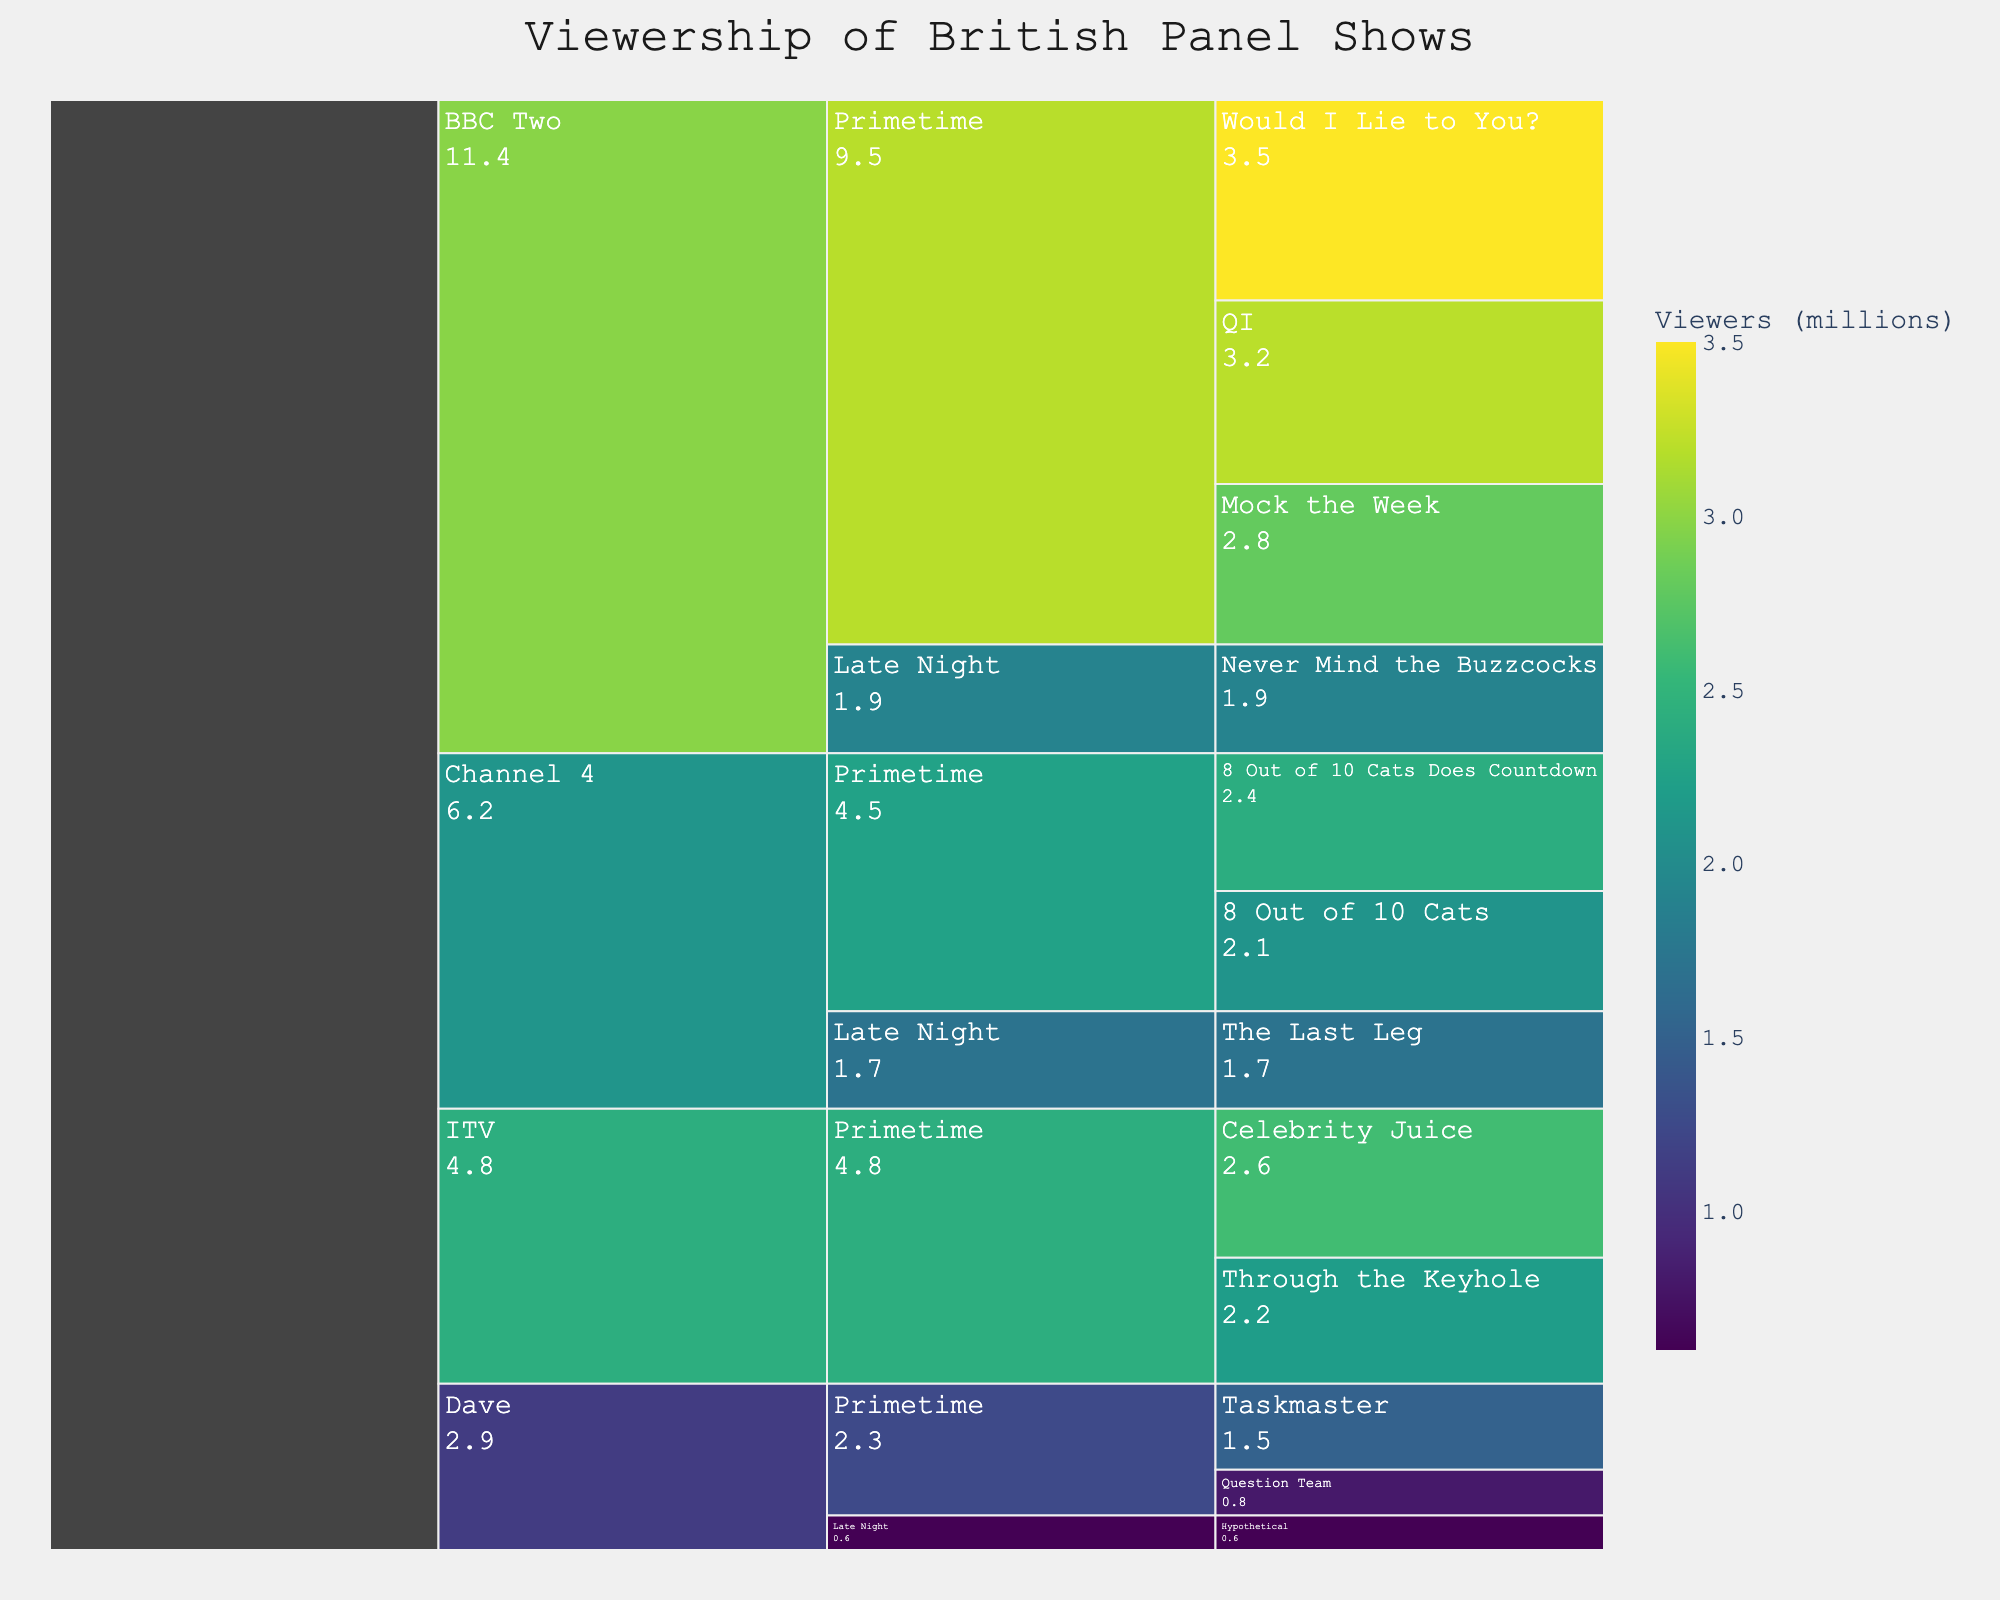How many channels are presented in the figure? The figure categorizes the data by channels, which are BBC Two, Channel 4, ITV, and Dave. Counting these gives a total of four channels.
Answer: Four Which show on BBC Two has the highest viewership? Navigate to the BBC Two subtree and compare the values of the shows listed. "Would I Lie to You?" has the largest value at 3.5 million viewers.
Answer: Would I Lie to You? What's the combined viewership of the IT and Channel 4 panel shows during Primetime? Add the viewership of Primetime shows under both channels. For Channel 4: 8 Out of 10 Cats (2.1) + 8 Out of 10 Cats Does Countdown (2.4) = 4.5 million. For ITV: Celebrity Juice (2.6) + Through the Keyhole (2.2) = 4.8 million. The combined viewership is 4.5 + 4.8 = 9.3 million.
Answer: 9.3 million What's the difference in viewership between the highest and lowest watched shows on Dave? Identify the highest (Taskmaster with 1.5 million) and lowest (Hypothetical with 0.6 million) viewed shows on Dave. Calculate the difference: 1.5 - 0.6 = 0.9 million.
Answer: 0.9 million Which channel has the least number of viewers during the Late Night time slot? Navigate to the Late Night subtree for each channel. Dave shows Hypothetical with 0.6 million viewers. Channel 4 shows The Last Leg with 1.7 million, and BBC Two has Never Mind the Buzzcocks with 1.9 million. The least is Dave with 0.6 million.
Answer: Dave Which show on the chart has a mid-level viewership close to the median of viewership values presented? List all viewership values and find the median. The values are 3.5, 3.2, 2.8, 2.6, 2.4, 2.2, 2.1, 1.9, 1.7, 1.5, 0.8, 0.6. The median values are the averages of the 6th and 7th in sorted list: (2.2 + 2.4)/2 = 2.3. Comparing values, the closest show is 8 Out of 10 Cats Does Countdown with 2.4 million. The difference of 0.1 is the smallest.
Answer: 8 Out of 10 Cats Does Countdown How many shows drew more than 2 million viewers? Check all viewership values exceeding 2 million. They are 3.5, 3.2, 2.8, 2.6, 2.4, 2.2, 2.1. Counting these gives 7 shows.
Answer: Seven Which time slot on BBC Two has the largest combined viewership? Sum the viewership of BBC Two's shows by each time slot. For Primetime: QI (3.2) + Mock the Week (2.8) + Would I Lie to You? (3.5) = 9.5 million. For Late Night: Never Mind the Buzzcocks = 1.9 million. Comparing these, Primetime has more viewership at 9.5 million.
Answer: Primetime What's the average viewership of all the shows on Channel 4? Sum the viewership of Channel 4 shows and divide by number of shows. Viewership is 2.1 + 2.4 + 1.7 = 6.2. There are three shows, so average is 6.2/3 ≈ 2.07 million.
Answer: 2.07 million Which of ITV's shows has the smallest viewership? Refer to ITV's subtree and compare: Celebrity Juice with 2.6 and Through the Keyhole with 2.2 million. The smallest is Through the Keyhole with 2.2 million.
Answer: Through the Keyhole 